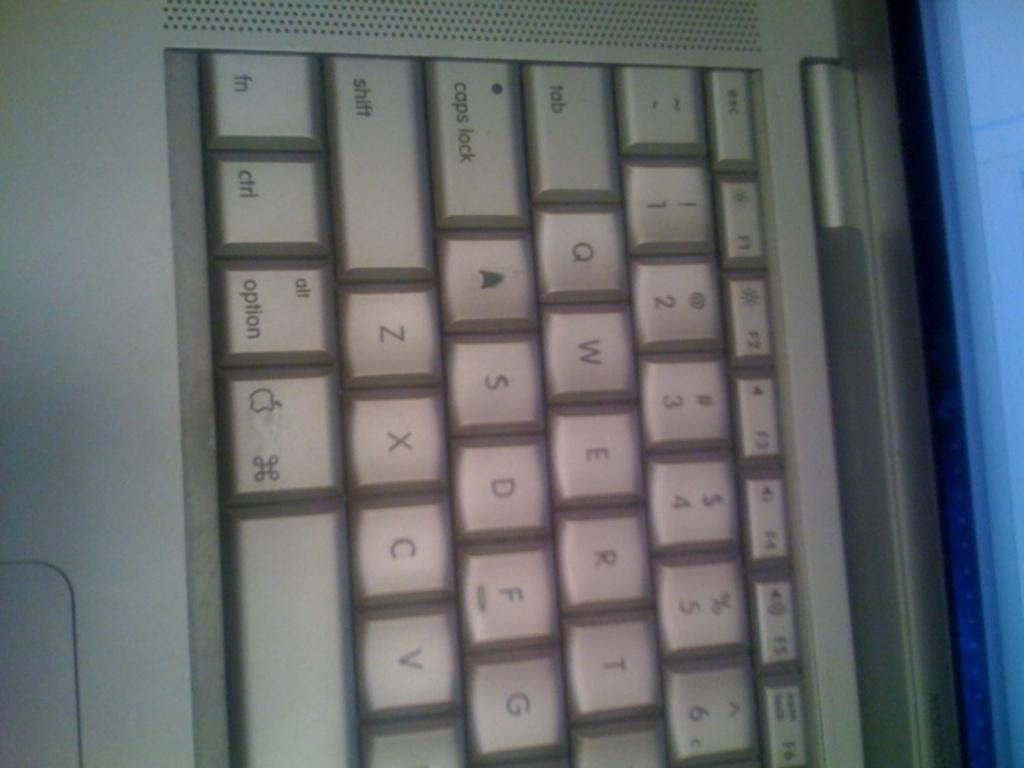<image>
Provide a brief description of the given image. The left side of a keyboard is visible, including keys such as shift and option. 